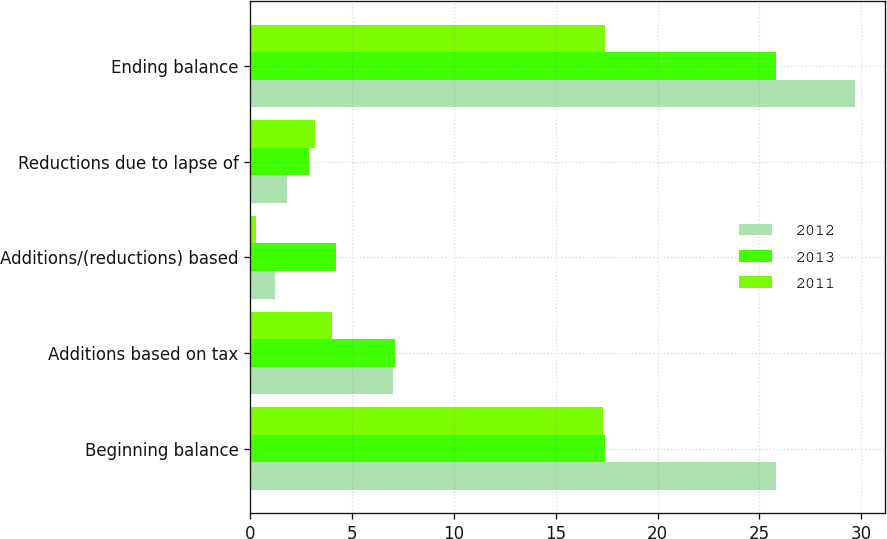<chart> <loc_0><loc_0><loc_500><loc_500><stacked_bar_chart><ecel><fcel>Beginning balance<fcel>Additions based on tax<fcel>Additions/(reductions) based<fcel>Reductions due to lapse of<fcel>Ending balance<nl><fcel>2012<fcel>25.8<fcel>7<fcel>1.2<fcel>1.8<fcel>29.7<nl><fcel>2013<fcel>17.4<fcel>7.1<fcel>4.2<fcel>2.9<fcel>25.8<nl><fcel>2011<fcel>17.3<fcel>4<fcel>0.3<fcel>3.2<fcel>17.4<nl></chart> 